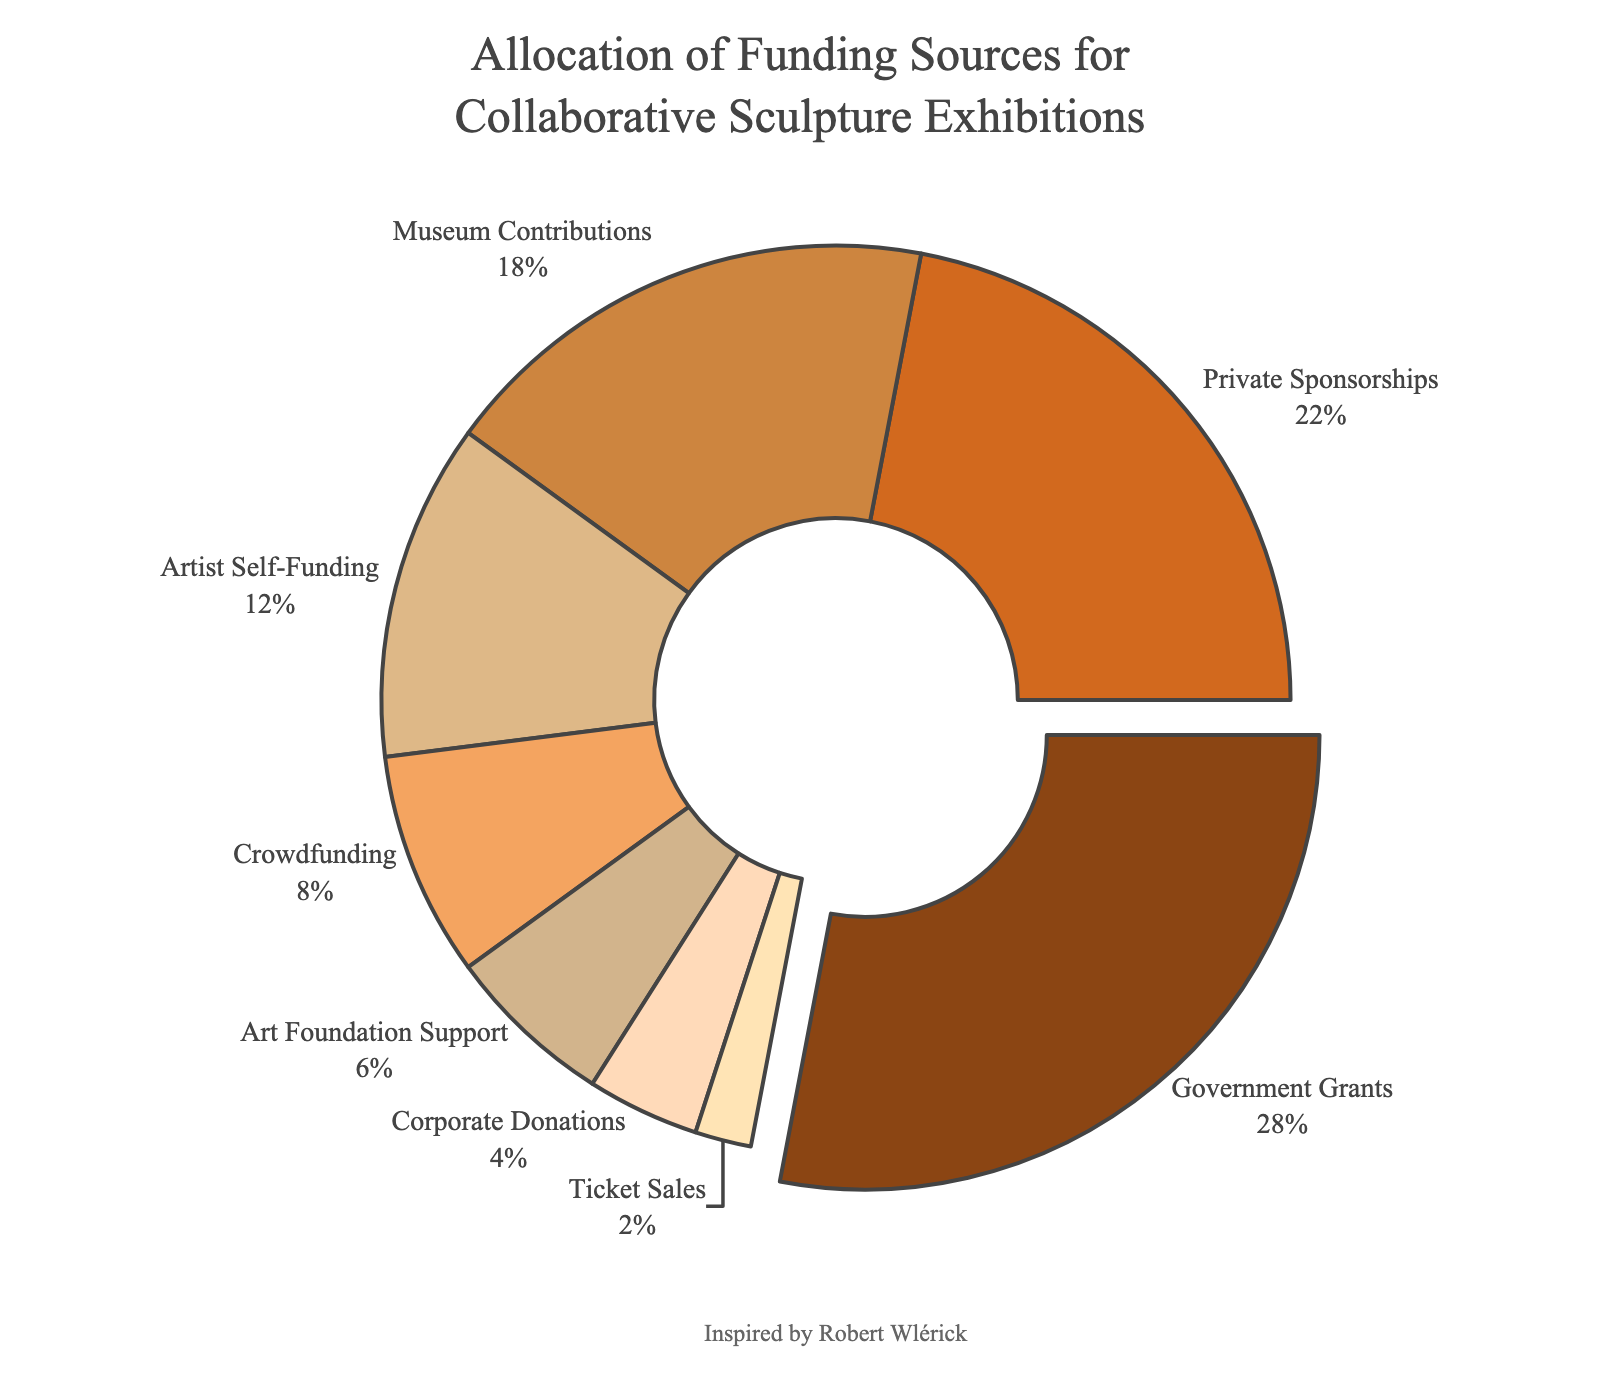How much is contributed by Government Grants and Private Sponsorships combined? Government Grants contribute 28% and Private Sponsorships contribute 22%. The combined amount is 28% + 22% = 50%.
Answer: 50% Which funding category contributes the least to the collaborative sculpture exhibitions? The category contributing the least percentage is Ticket Sales with 2%.
Answer: Ticket Sales How many categories contribute more than 15% each? Categories that contribute more than 15% are Government Grants (28%), Private Sponsorships (22%), and Museum Contributions (18%). So, there are 3 categories in total.
Answer: 3 Which category is visually represented with the bulge-out/pulled-out slice of the pie chart? The largest percentage slice, which is pulled out, corresponds to Government Grants at 28%.
Answer: Government Grants How does the contribution from Art Foundation Support compare to that from Corporate Donations? Art Foundation Support contributes 6%, while Corporate Donations contribute 4%. Art Foundation Support contributes 2% more than Corporate Donations.
Answer: Art Foundation Support contributes 2% more If the contributions from Artist Self-Funding doubled, what would its new percentage be, and how would it compare to Government Grants? Current Artist Self-Funding is 12%. If it doubles, it becomes 12% * 2 = 24%. Comparing it to Government Grants, which is 28%, Artist Self-Funding would still be 4% less.
Answer: New percentage: 24%, 4% less than Government Grants Which categories contribute less than 10% each, and what is their combined percentage? Categories that contribute less than 10% are Crowdfunding (8%), Art Foundation Support (6%), Corporate Donations (4%), and Ticket Sales (2%). Their combined percentage is 8% + 6% + 4% + 2% = 20%.
Answer: Combined percentage: 20% What is the percentage difference between Museum Contributions and Artist Self-Funding? Museum Contributions are 18% and Artist Self-Funding is 12%. The percentage difference is 18% - 12% = 6%.
Answer: 6% Which two categories have the closest contribution percentages? Art Foundation Support (6%) and Corporate Donations (4%) have a difference of only 2%, making them the closest in contribution percentages.
Answer: Art Foundation Support and Corporate Donations 